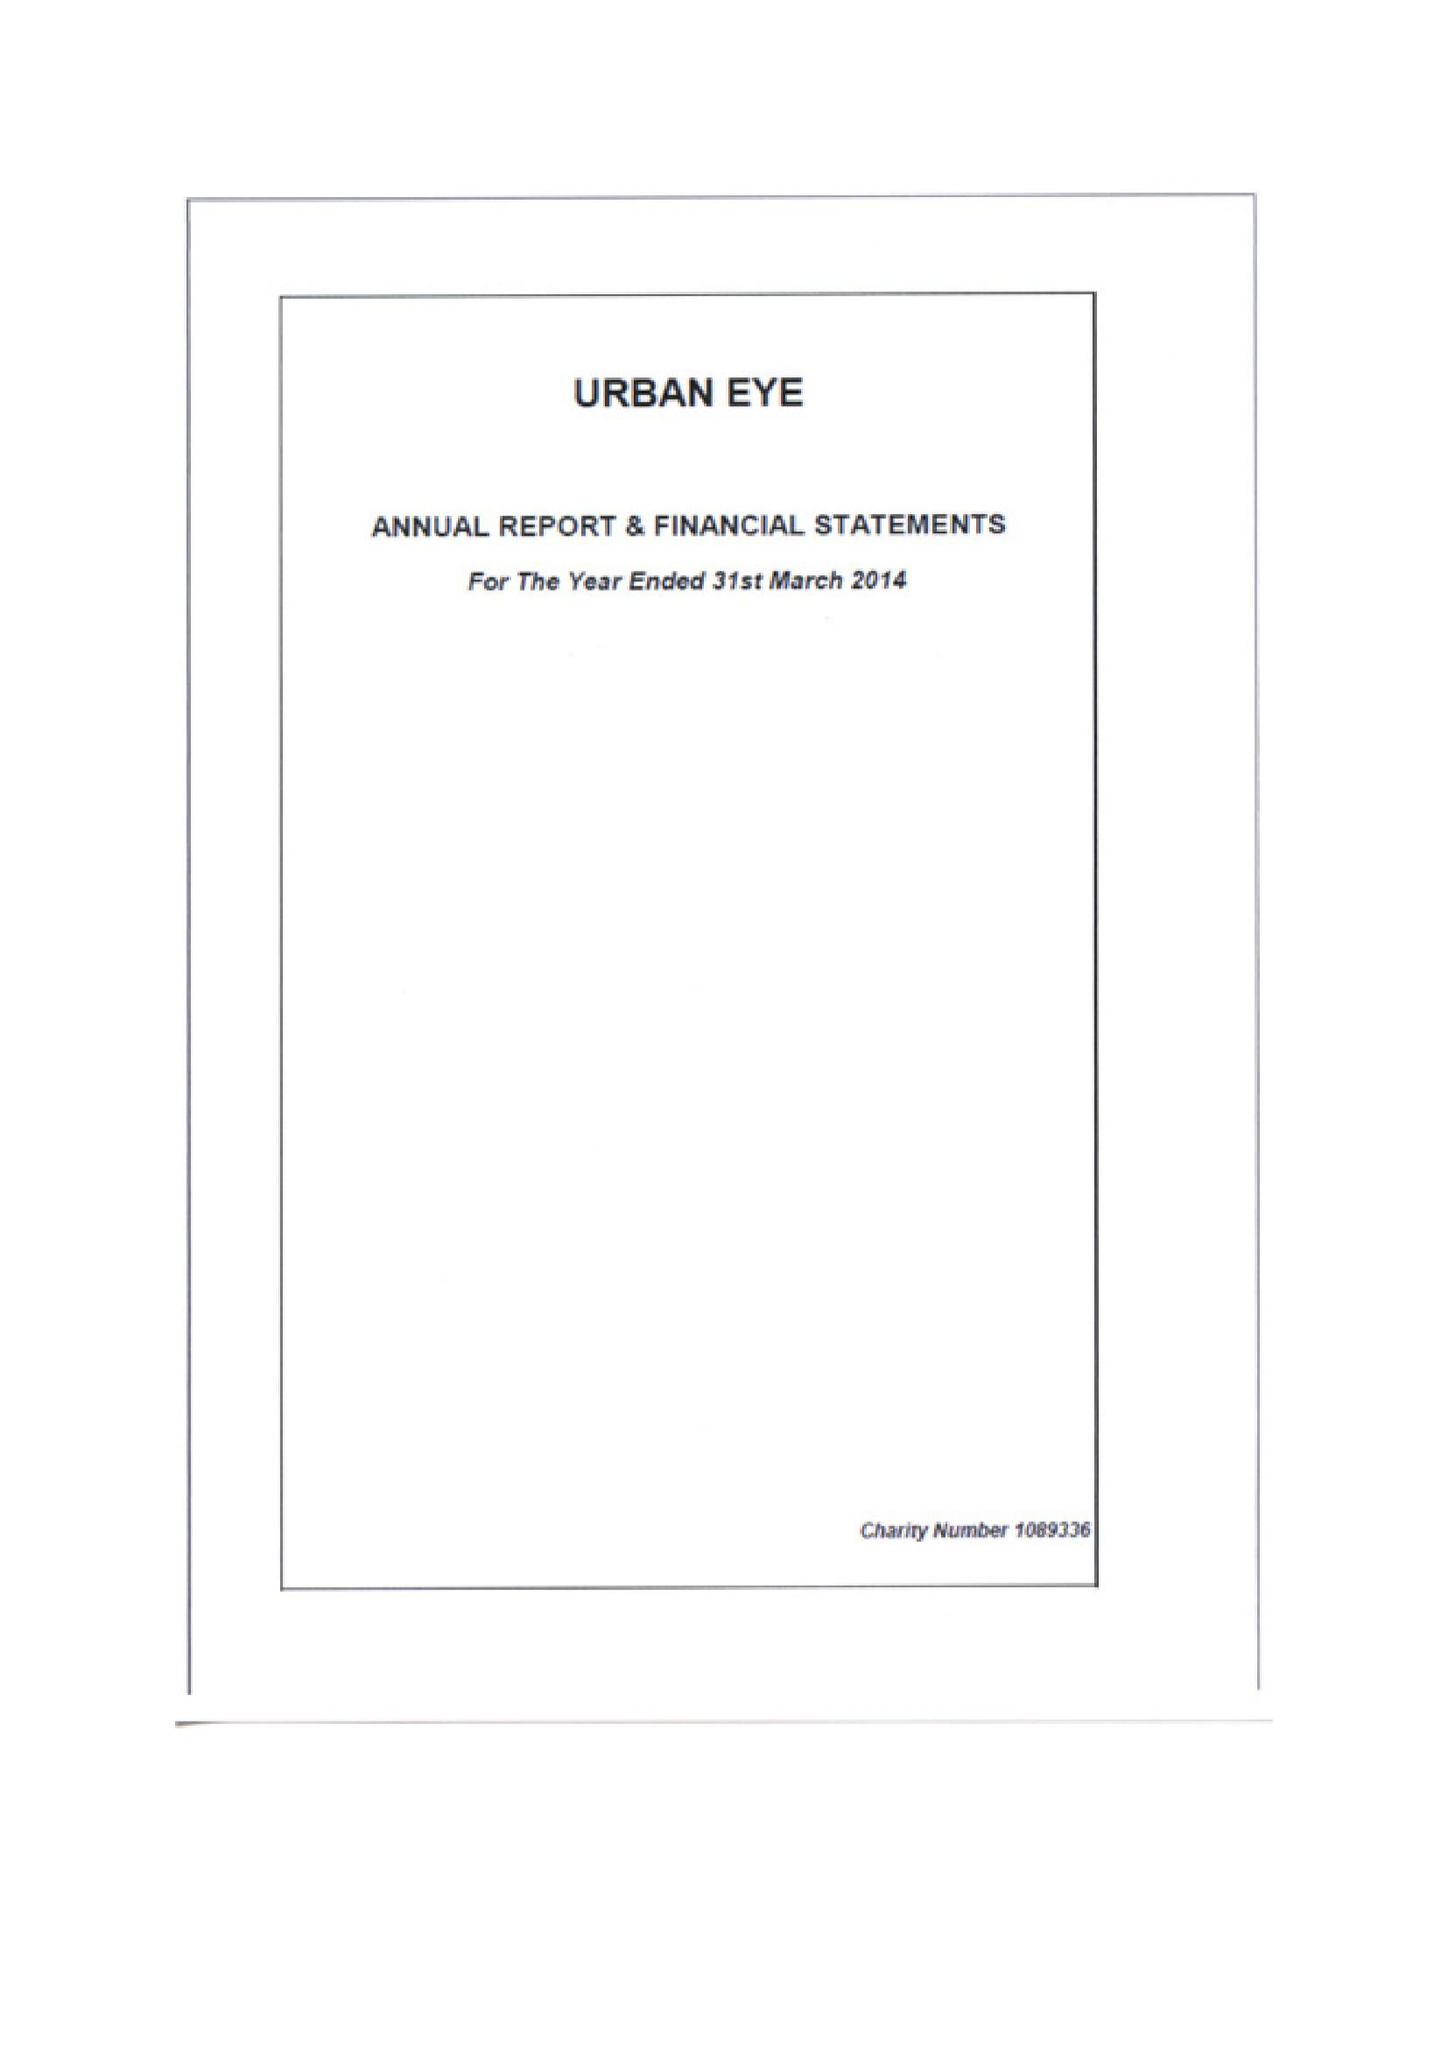What is the value for the charity_name?
Answer the question using a single word or phrase. Urban Eye 